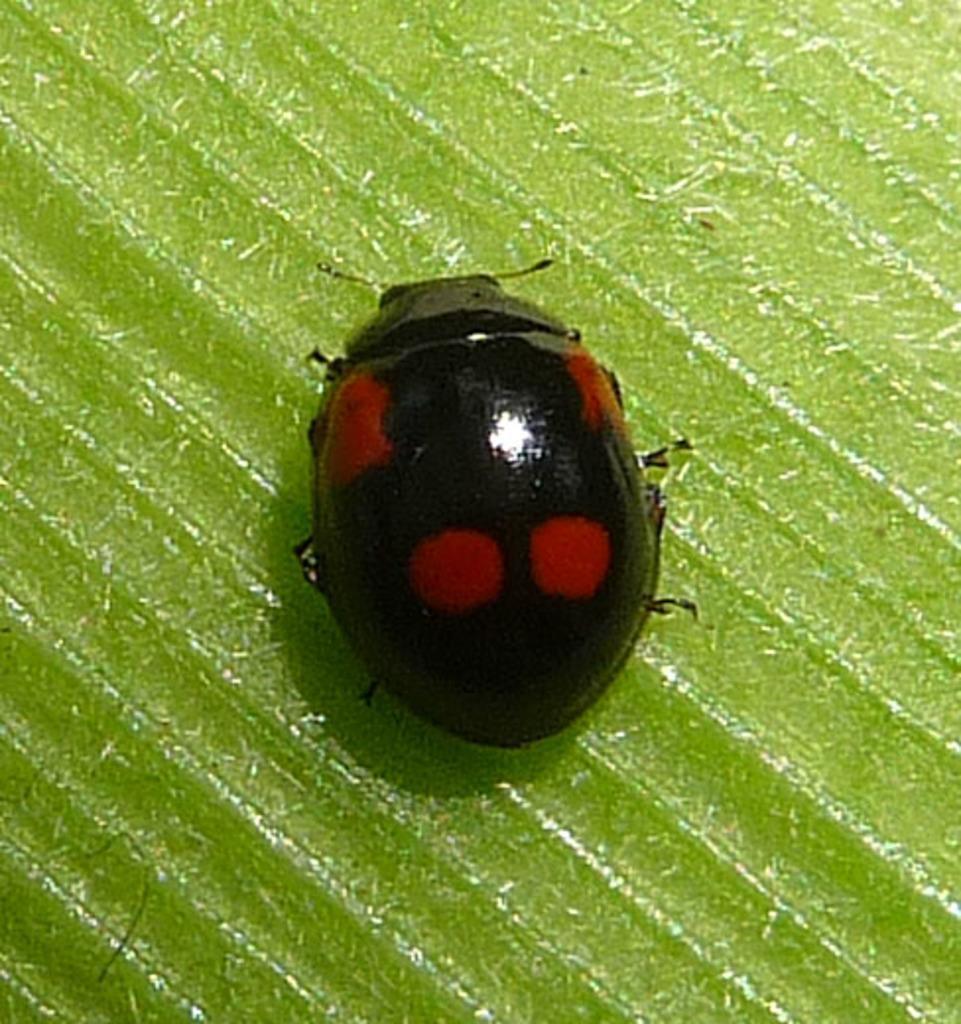Can you describe this image briefly? In this image I can see an insect which is in red and black color. And there is a green color background. 